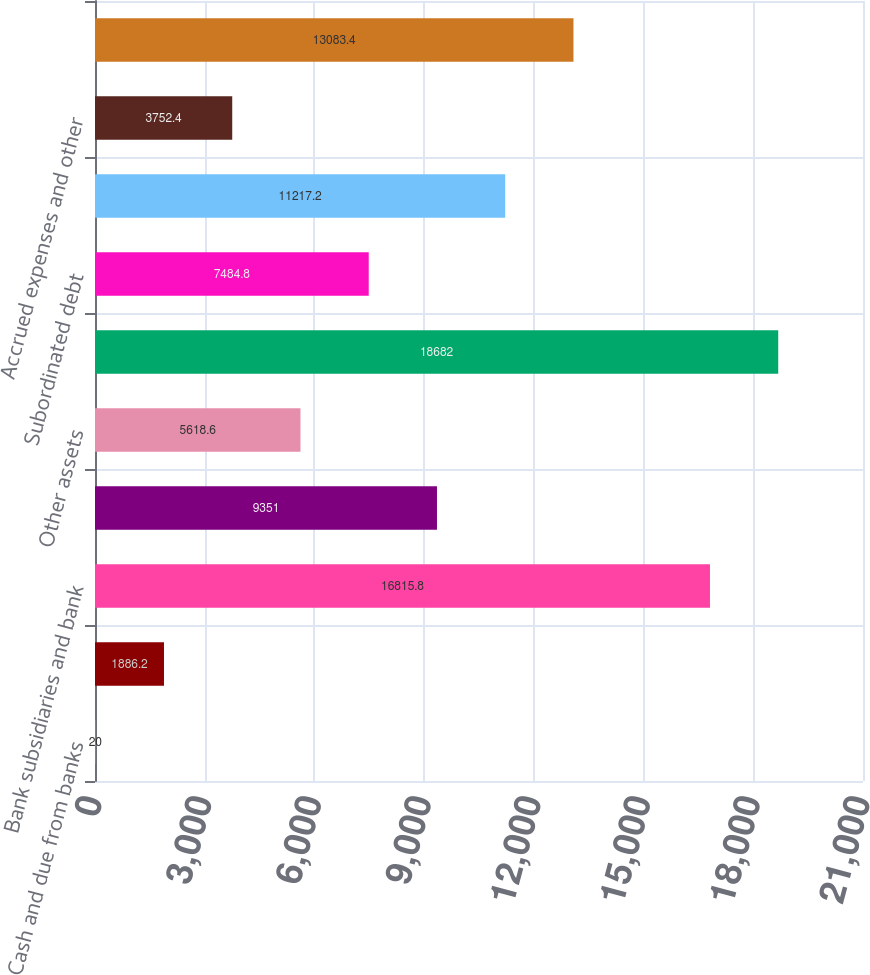<chart> <loc_0><loc_0><loc_500><loc_500><bar_chart><fcel>Cash and due from banks<fcel>Short-term investments<fcel>Bank subsidiaries and bank<fcel>Non-bank subsidiaries<fcel>Other assets<fcel>Total assets<fcel>Subordinated debt<fcel>Nonbank affiliate borrowings<fcel>Accrued expenses and other<fcel>Total liabilities<nl><fcel>20<fcel>1886.2<fcel>16815.8<fcel>9351<fcel>5618.6<fcel>18682<fcel>7484.8<fcel>11217.2<fcel>3752.4<fcel>13083.4<nl></chart> 